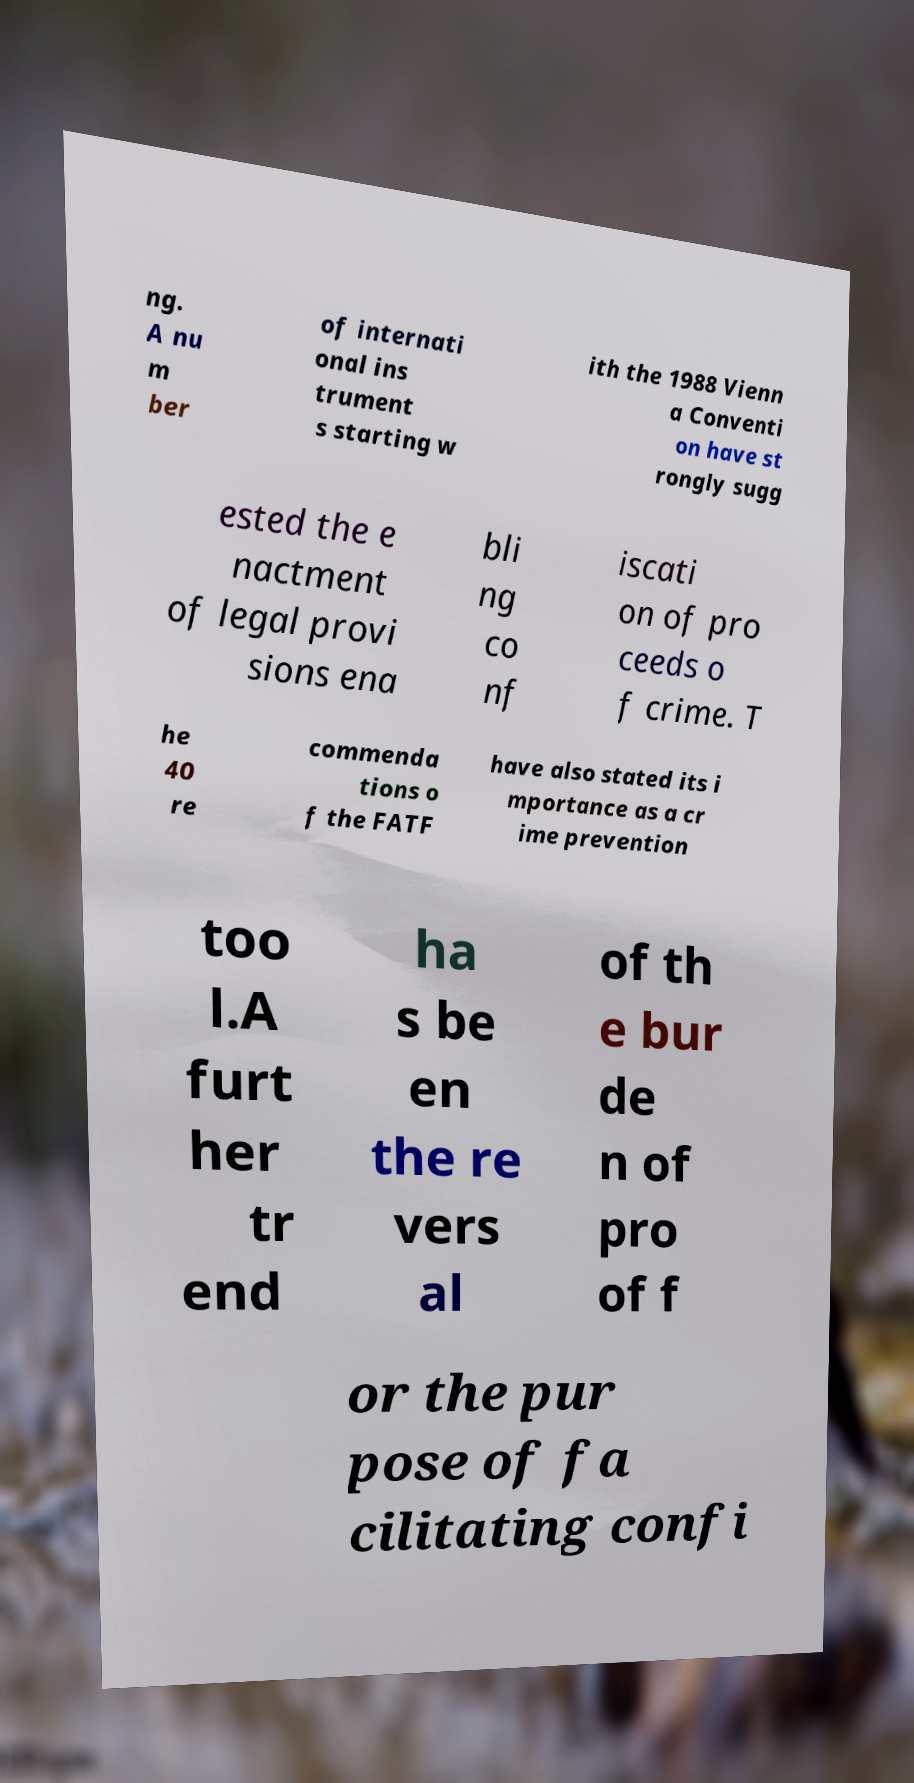There's text embedded in this image that I need extracted. Can you transcribe it verbatim? ng. A nu m ber of internati onal ins trument s starting w ith the 1988 Vienn a Conventi on have st rongly sugg ested the e nactment of legal provi sions ena bli ng co nf iscati on of pro ceeds o f crime. T he 40 re commenda tions o f the FATF have also stated its i mportance as a cr ime prevention too l.A furt her tr end ha s be en the re vers al of th e bur de n of pro of f or the pur pose of fa cilitating confi 